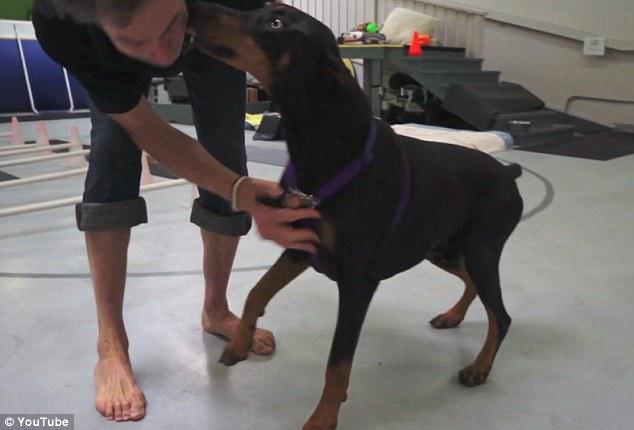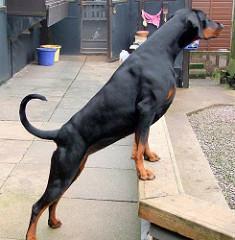The first image is the image on the left, the second image is the image on the right. Evaluate the accuracy of this statement regarding the images: "There are more dogs in the image on the left.". Is it true? Answer yes or no. No. The first image is the image on the left, the second image is the image on the right. Examine the images to the left and right. Is the description "A person is bending down behind a standing doberman, with one hand holding the front of the dog under its head." accurate? Answer yes or no. Yes. 